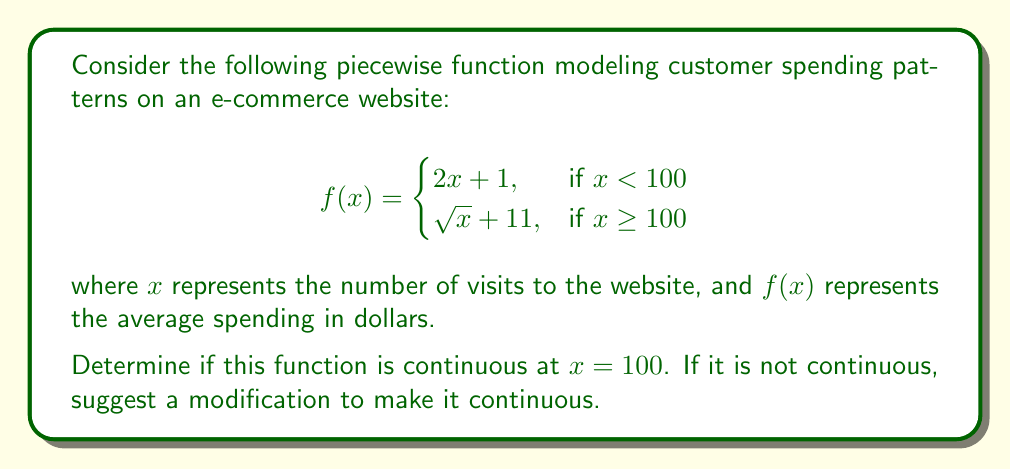Could you help me with this problem? To determine if the function is continuous at $x = 100$, we need to check three conditions:

1. $f(x)$ is defined at $x = 100$
2. $\lim_{x \to 100^-} f(x)$ exists
3. $\lim_{x \to 100^+} f(x)$ exists
4. $\lim_{x \to 100^-} f(x) = \lim_{x \to 100^+} f(x) = f(100)$

Let's check each condition:

1. $f(100)$ is defined: $f(100) = \sqrt{100} + 11 = 21$

2. $\lim_{x \to 100^-} f(x) = \lim_{x \to 100^-} (2x + 1) = 2(100) + 1 = 201$

3. $\lim_{x \to 100^+} f(x) = \lim_{x \to 100^+} (\sqrt{x} + 11) = \sqrt{100} + 11 = 21$

4. We can see that $\lim_{x \to 100^-} f(x) \neq \lim_{x \to 100^+} f(x)$

Therefore, the function is not continuous at $x = 100$.

To make the function continuous, we need to modify the first piece of the function so that it matches the second piece at $x = 100$. We can do this by changing the coefficient of $x$ in the first piece:

$$f(x) = \begin{cases}
0.1x + 11, & \text{if } x < 100 \\
\sqrt{x} + 11, & \text{if } x \geq 100
\end{cases}$$

Now, $\lim_{x \to 100^-} f(x) = 0.1(100) + 11 = 21$, which matches $f(100)$ and $\lim_{x \to 100^+} f(x)$.
Answer: Not continuous; modify first piece to $0.1x + 11$ for continuity. 